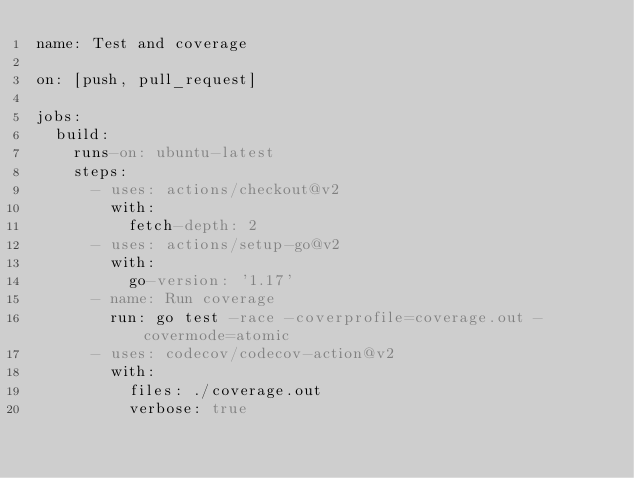<code> <loc_0><loc_0><loc_500><loc_500><_YAML_>name: Test and coverage

on: [push, pull_request]

jobs:
  build:
    runs-on: ubuntu-latest
    steps:
      - uses: actions/checkout@v2
        with:
          fetch-depth: 2
      - uses: actions/setup-go@v2
        with:
          go-version: '1.17'
      - name: Run coverage
        run: go test -race -coverprofile=coverage.out -covermode=atomic
      - uses: codecov/codecov-action@v2
        with:
          files: ./coverage.out
          verbose: true
</code> 